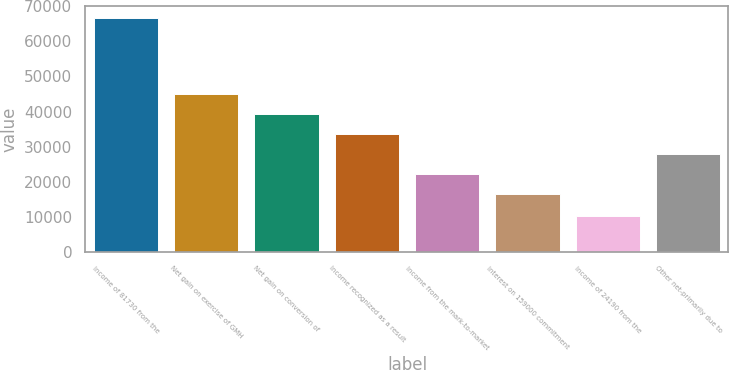<chart> <loc_0><loc_0><loc_500><loc_500><bar_chart><fcel>Income of 81730 from the<fcel>Net gain on exercise of GMH<fcel>Net gain on conversion of<fcel>Income recognized as a result<fcel>Income from the mark-to-market<fcel>Interest on 159000 commitment<fcel>Income of 24190 from the<fcel>Other net-primarily due to<nl><fcel>66762<fcel>44907<fcel>39241.8<fcel>33576.6<fcel>22246.2<fcel>16581<fcel>10110<fcel>27911.4<nl></chart> 